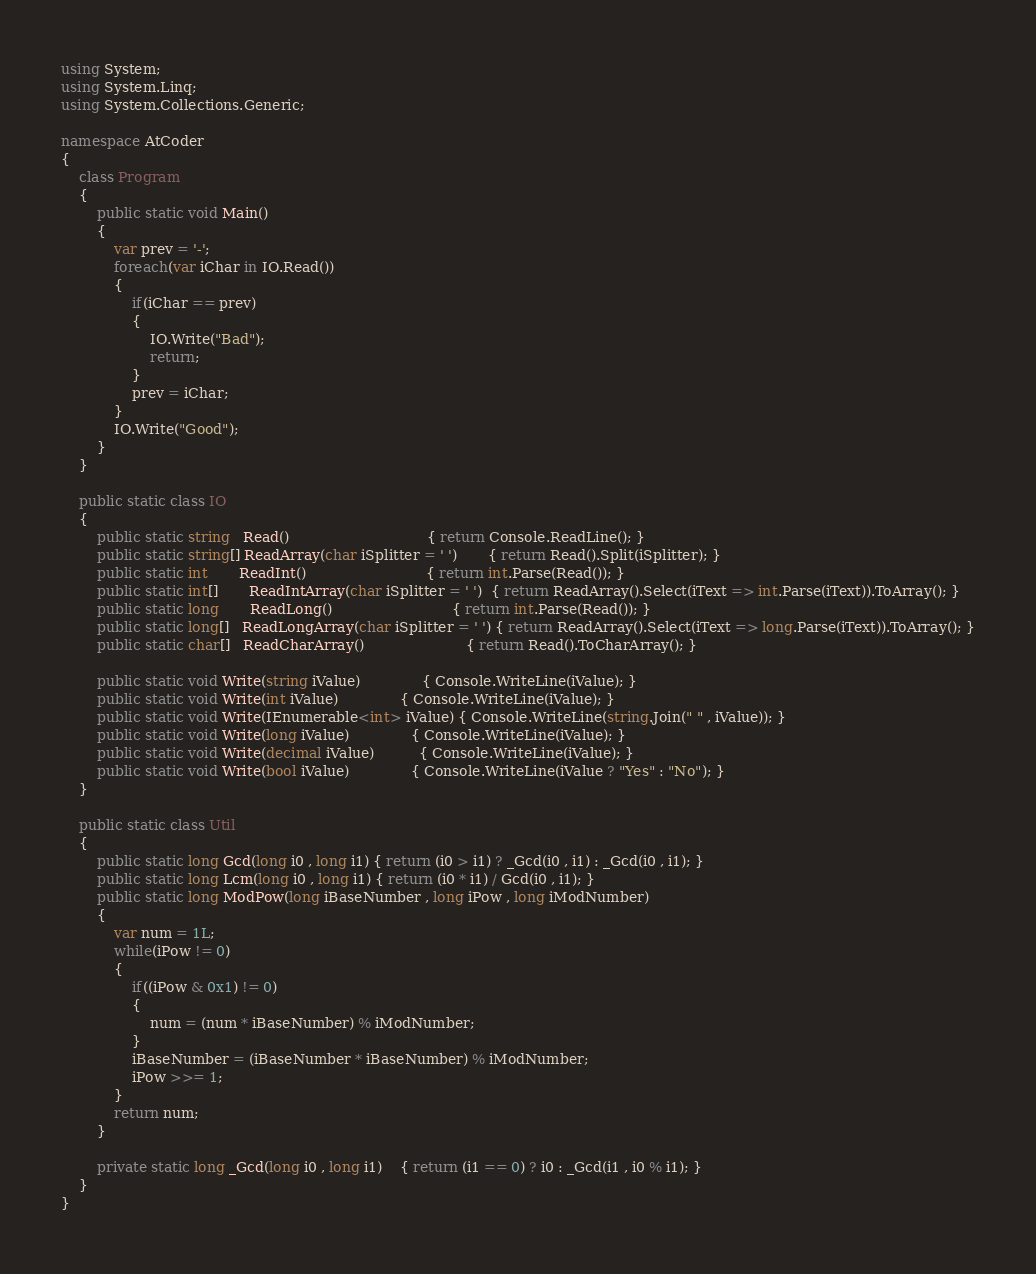<code> <loc_0><loc_0><loc_500><loc_500><_C#_>using System;
using System.Linq;
using System.Collections.Generic;

namespace AtCoder
{
	class Program
	{
		public static void Main()
		{
			var prev = '-';
			foreach(var iChar in IO.Read())
			{
				if(iChar == prev)
				{
					IO.Write("Bad");
					return;
				}
				prev = iChar;
			}
			IO.Write("Good");
		}
	}

	public static class IO
	{
		public static string   Read()							   { return Console.ReadLine(); }
		public static string[] ReadArray(char iSplitter = ' ')	   { return Read().Split(iSplitter); }
		public static int	   ReadInt()						   { return int.Parse(Read()); }
		public static int[]	   ReadIntArray(char iSplitter = ' ')  { return ReadArray().Select(iText => int.Parse(iText)).ToArray(); }
		public static long	   ReadLong()						   { return int.Parse(Read()); }
		public static long[]   ReadLongArray(char iSplitter = ' ') { return ReadArray().Select(iText => long.Parse(iText)).ToArray(); }
		public static char[]   ReadCharArray()					   { return Read().ToCharArray(); }

		public static void Write(string iValue)			  { Console.WriteLine(iValue); }
		public static void Write(int iValue)			  { Console.WriteLine(iValue); }
		public static void Write(IEnumerable<int> iValue) { Console.WriteLine(string.Join(" " , iValue)); }
		public static void Write(long iValue)			  { Console.WriteLine(iValue); }
		public static void Write(decimal iValue)		  { Console.WriteLine(iValue); }
		public static void Write(bool iValue)			  { Console.WriteLine(iValue ? "Yes" : "No"); }
	}

	public static class Util
	{
		public static long Gcd(long i0 , long i1) { return (i0 > i1) ? _Gcd(i0 , i1) : _Gcd(i0 , i1); }
		public static long Lcm(long i0 , long i1) { return (i0 * i1) / Gcd(i0 , i1); }
		public static long ModPow(long iBaseNumber , long iPow , long iModNumber)
		{
			var num = 1L;
			while(iPow != 0)
			{
				if((iPow & 0x1) != 0)
				{
					num = (num * iBaseNumber) % iModNumber;
				}
				iBaseNumber = (iBaseNumber * iBaseNumber) % iModNumber;
				iPow >>= 1;
			}
			return num;
		}

		private static long _Gcd(long i0 , long i1)	{ return (i1 == 0) ? i0 : _Gcd(i1 , i0 % i1); }
	}
}
</code> 